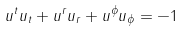<formula> <loc_0><loc_0><loc_500><loc_500>u ^ { t } u _ { t } + u ^ { r } u _ { r } + u ^ { \phi } u _ { \phi } = - 1</formula> 